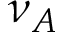Convert formula to latex. <formula><loc_0><loc_0><loc_500><loc_500>\nu _ { A }</formula> 